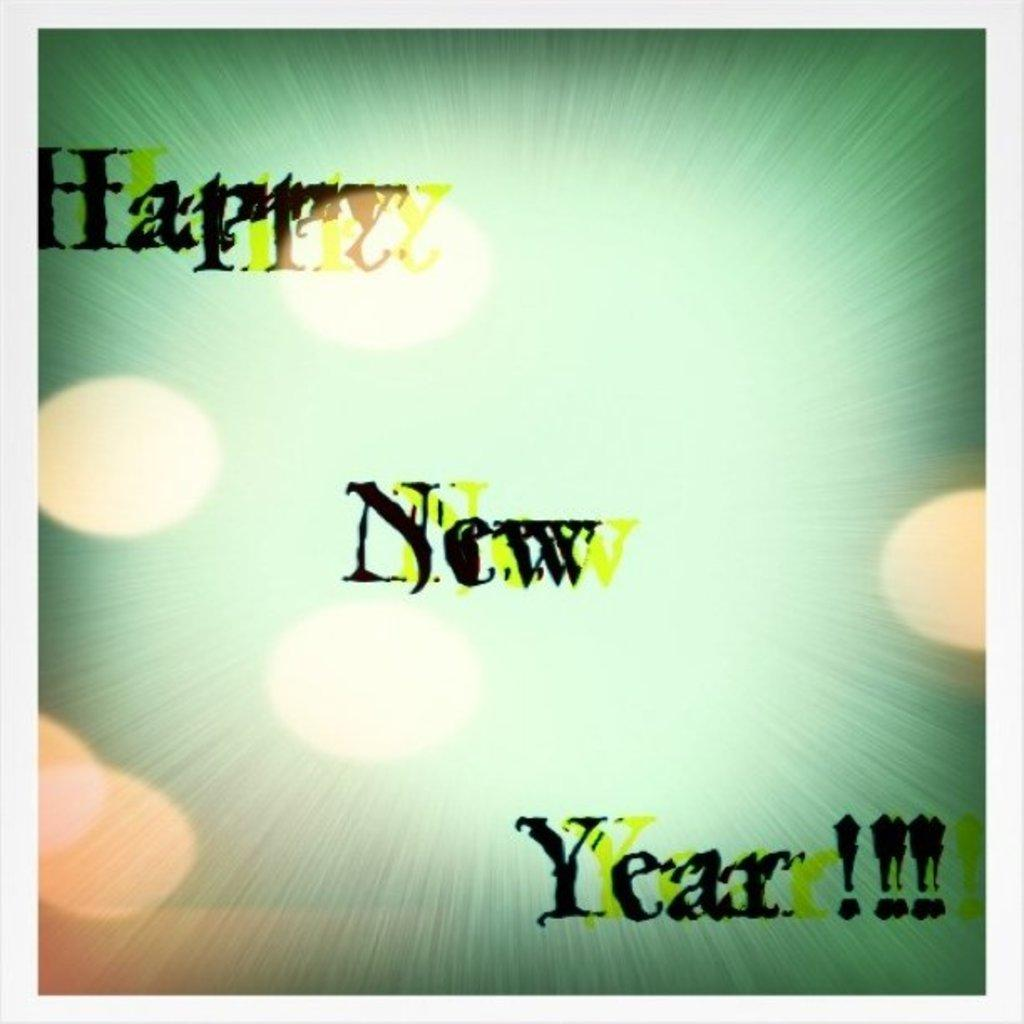<image>
Provide a brief description of the given image. An image with black and yellow text that reads "Happy New Year." 